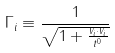Convert formula to latex. <formula><loc_0><loc_0><loc_500><loc_500>\Gamma _ { i } \equiv \frac { 1 } { \sqrt { 1 + \frac { v _ { i } \cdot v _ { i } } { t ^ { 0 } } } }</formula> 